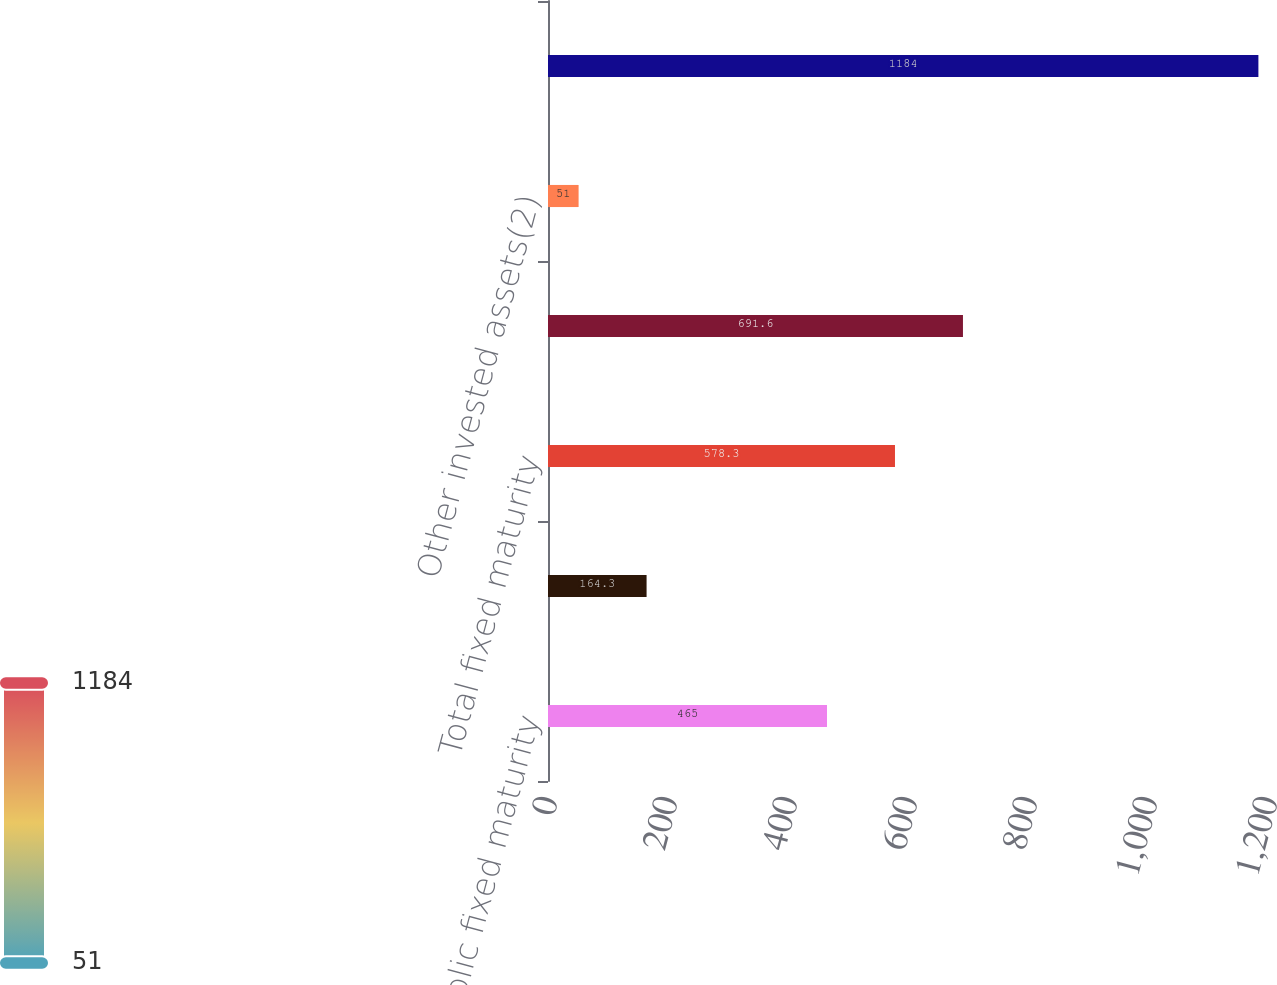Convert chart. <chart><loc_0><loc_0><loc_500><loc_500><bar_chart><fcel>Public fixed maturity<fcel>Private fixed maturity<fcel>Total fixed maturity<fcel>Equity securities<fcel>Other invested assets(2)<fcel>Total<nl><fcel>465<fcel>164.3<fcel>578.3<fcel>691.6<fcel>51<fcel>1184<nl></chart> 